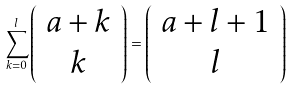<formula> <loc_0><loc_0><loc_500><loc_500>\sum _ { k = 0 } ^ { l } \left ( \begin{array} { c } a + k \\ k \end{array} \right ) = \left ( \begin{array} { c } a + l + 1 \\ l \end{array} \right )</formula> 